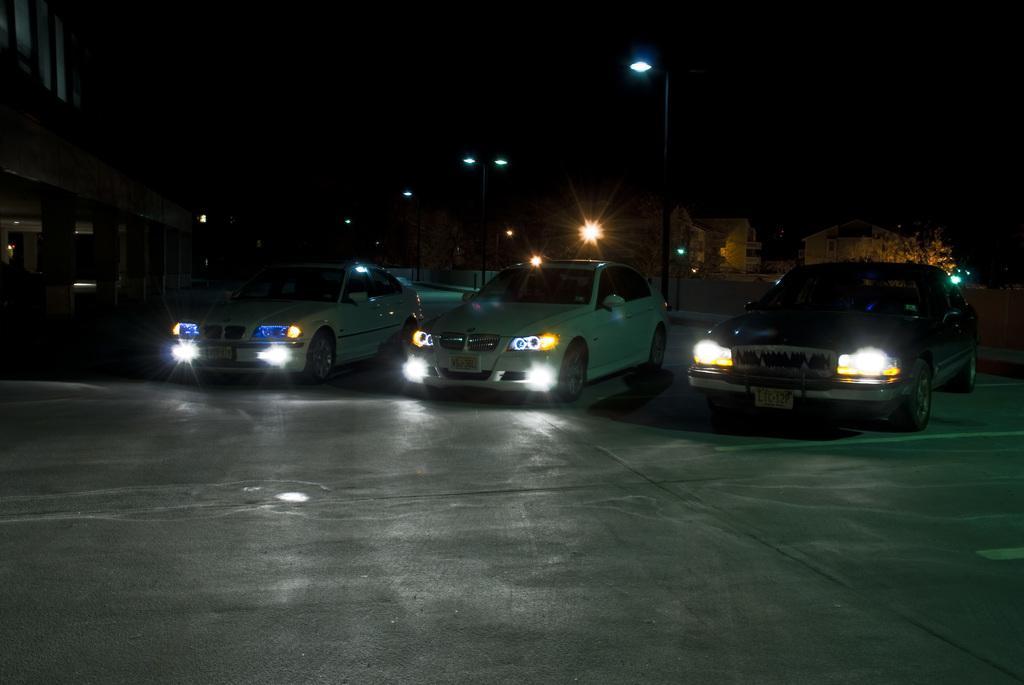How would you summarize this image in a sentence or two? In the center of the image we can see cars on the road. In the background there are pole, lights, trees and buildings. 